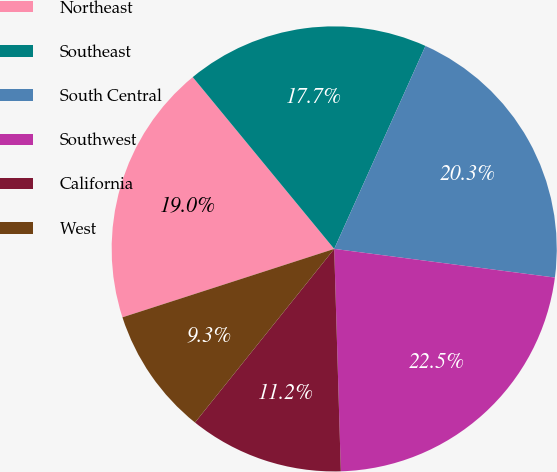Convert chart to OTSL. <chart><loc_0><loc_0><loc_500><loc_500><pie_chart><fcel>Northeast<fcel>Southeast<fcel>South Central<fcel>Southwest<fcel>California<fcel>West<nl><fcel>19.01%<fcel>17.69%<fcel>20.33%<fcel>22.47%<fcel>11.23%<fcel>9.27%<nl></chart> 